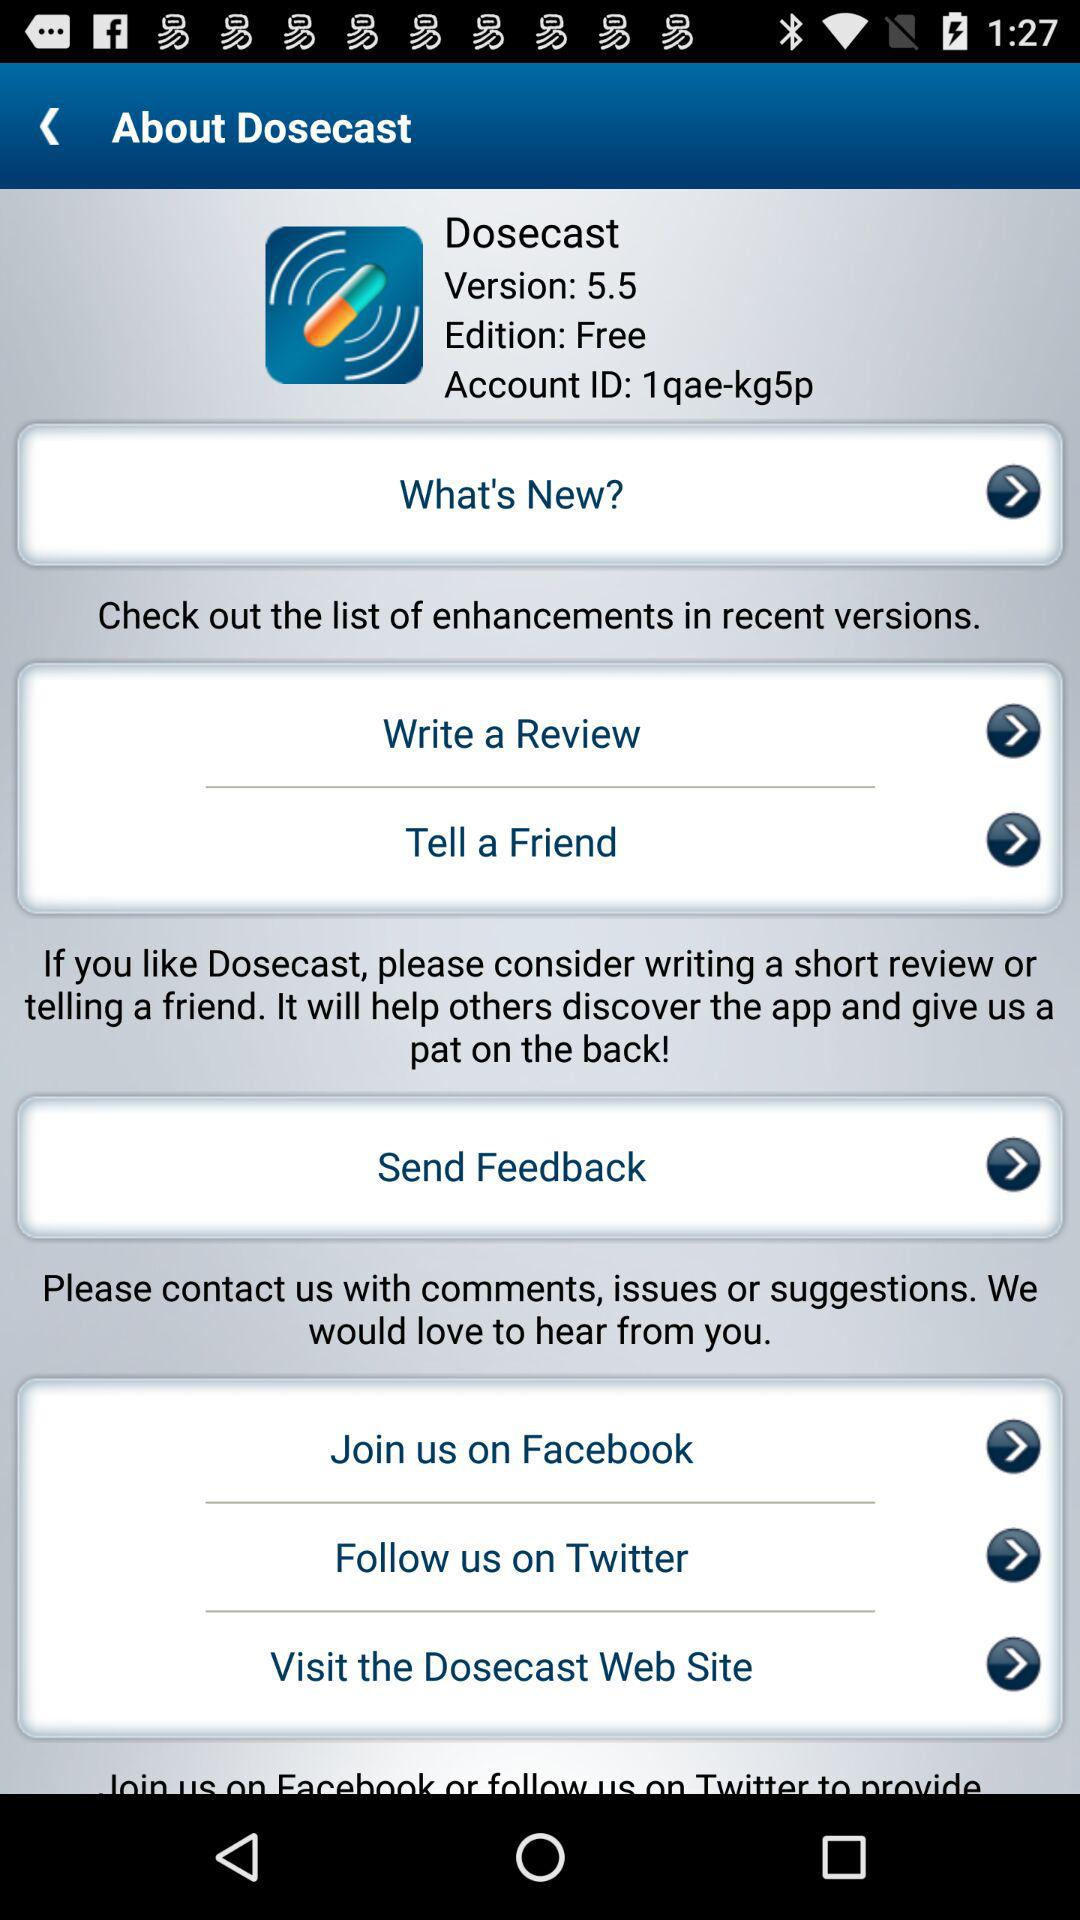What are the options available to contact them? The options available to contact them are comments, issues or suggestions. 